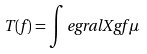<formula> <loc_0><loc_0><loc_500><loc_500>T ( f ) = \int e g r a l { X } { g f } { \mu }</formula> 